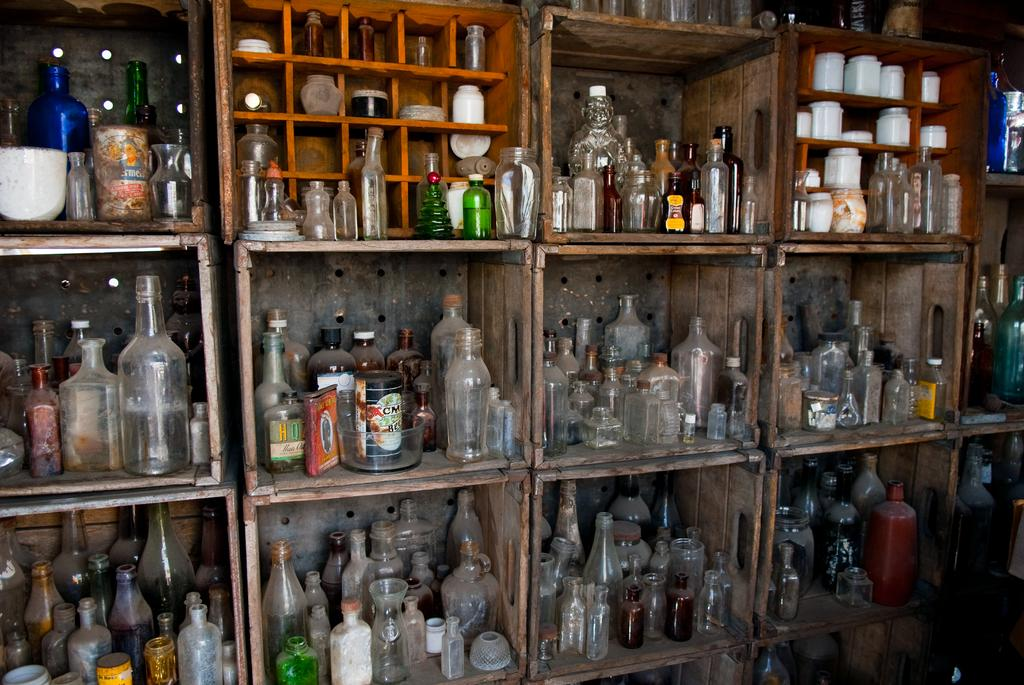What objects are arranged in a rack in the image? There are bottles in a rack in the image. How are the bottles positioned in the image? The bottles are arranged in a rack, which suggests they are organized and easily accessible. Can you describe the bottles in the rack? Unfortunately, the image does not provide enough detail to describe the bottles in the rack. What suggestions do the babies in the image have for improving the territory? There are no babies present in the image, so it is not possible to answer that question. 